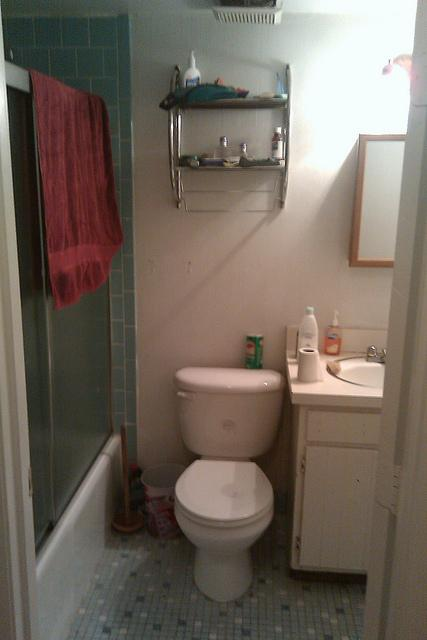What is in the container on the toilet tank? cleaning product 